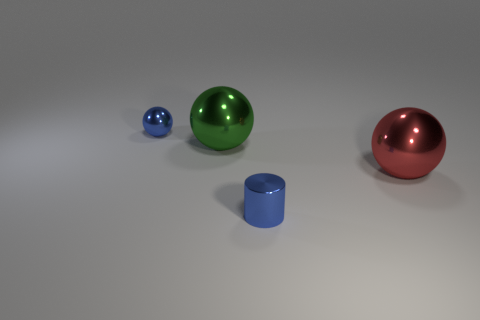Subtract all big metal spheres. How many spheres are left? 1 Subtract 1 balls. How many balls are left? 2 Add 1 blue metal cylinders. How many objects exist? 5 Subtract all cylinders. How many objects are left? 3 Add 3 small blue metallic things. How many small blue metallic things exist? 5 Subtract 0 brown cylinders. How many objects are left? 4 Subtract all blue metallic things. Subtract all small blue metal objects. How many objects are left? 0 Add 1 small blue balls. How many small blue balls are left? 2 